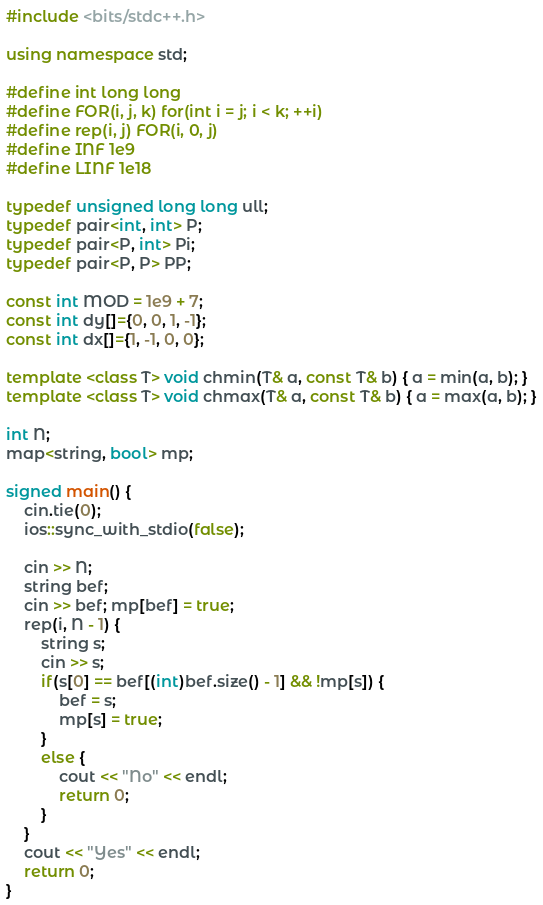<code> <loc_0><loc_0><loc_500><loc_500><_C++_>#include <bits/stdc++.h>  

using namespace std;

#define int long long
#define FOR(i, j, k) for(int i = j; i < k; ++i)
#define rep(i, j) FOR(i, 0, j)
#define INF 1e9
#define LINF 1e18

typedef unsigned long long ull;
typedef pair<int, int> P;
typedef pair<P, int> Pi;
typedef pair<P, P> PP;

const int MOD = 1e9 + 7;
const int dy[]={0, 0, 1, -1};
const int dx[]={1, -1, 0, 0};

template <class T> void chmin(T& a, const T& b) { a = min(a, b); }
template <class T> void chmax(T& a, const T& b) { a = max(a, b); }

int N;
map<string, bool> mp;

signed main() {
    cin.tie(0);
    ios::sync_with_stdio(false);

    cin >> N;
    string bef;
    cin >> bef; mp[bef] = true;
    rep(i, N - 1) {
        string s;
        cin >> s;
        if(s[0] == bef[(int)bef.size() - 1] && !mp[s]) {
            bef = s;
            mp[s] = true;
        }
        else {
            cout << "No" << endl;
            return 0;
        }
    }
    cout << "Yes" << endl;
    return 0;
}</code> 